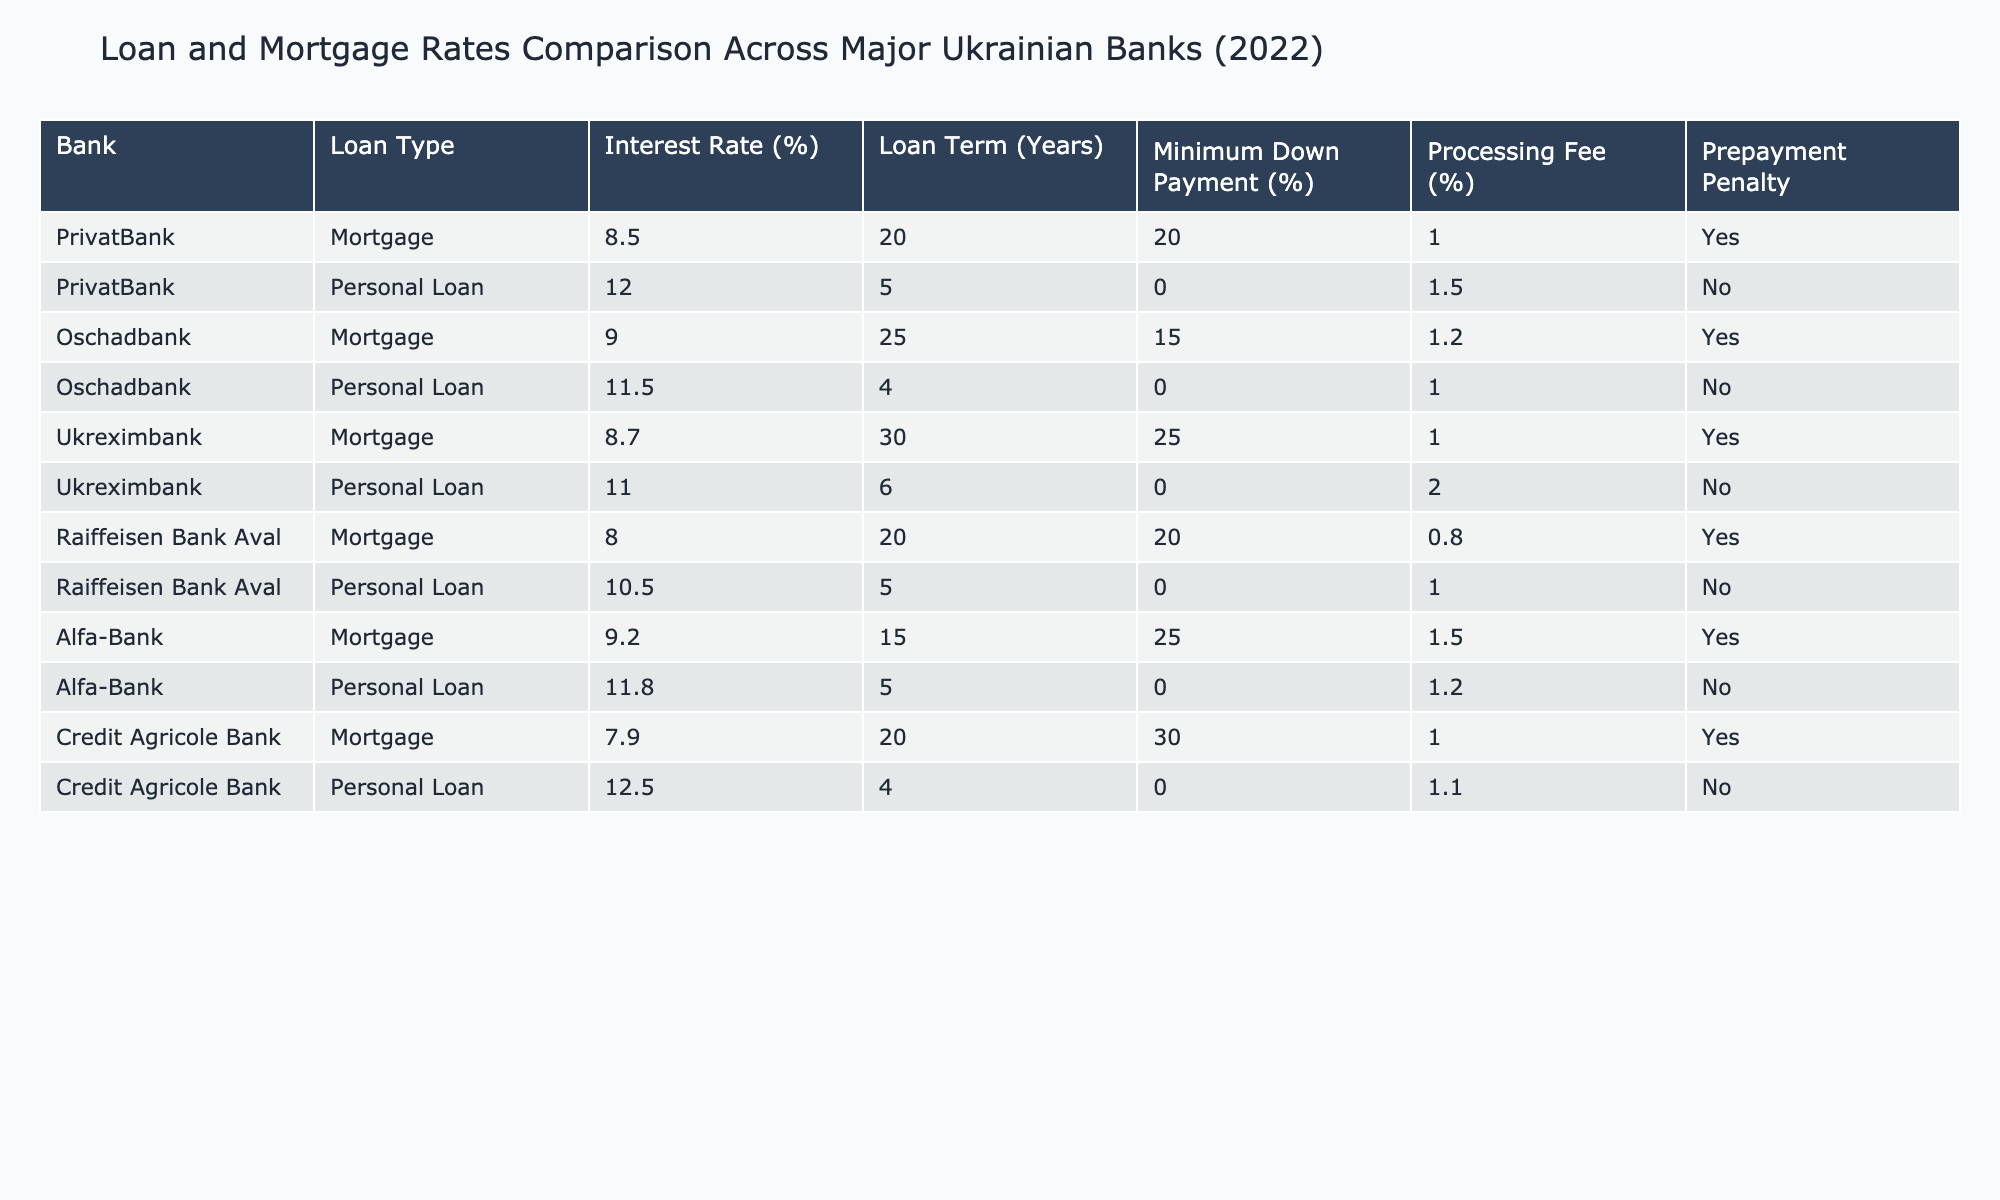What is the interest rate for a mortgage at PrivatBank? The table lists the interest rate for mortgage loans at PrivatBank as 8.5%.
Answer: 8.5% Which bank offers the lowest interest rate for personal loans? By reviewing the personal loan interest rates from each bank, it shows that Raiffeisen Bank Aval has the lowest rate at 10.5%.
Answer: 10.5% What is the maximum loan term available for mortgages at Oschadbank? According to the table, Oschadbank offers mortgage loans with a maximum term of 25 years.
Answer: 25 years Is there a prepayment penalty for loans from Alfa-Bank? The data indicates that for both types of loans At Alfa-Bank, there is no prepayment penalty.
Answer: No What is the difference in interest rates between Credit Agricole Bank’s mortgage and personal loan? The mortgage interest rate is 7.9% and the personal loan rate is 12.5%, so the difference is 12.5% - 7.9% = 4.6%.
Answer: 4.6% How many banks provide mortgages with an interest rate below 9%? The table shows that three banks (Credit Agricole Bank, Raiffeisen Bank Aval, and PrivatBank) offer mortgages with rates below 9%. Therefore, the total is three banks.
Answer: 3 banks What is the average interest rate for mortgages across all banks listed? To find the average, add the interest rates (8.5% + 9.0% + 8.7% + 8.0% + 9.2% + 7.9%) totaling 51.3%. Dividing by 6 (the number of banks) results in an average of 8.55%.
Answer: 8.55% Do Ukreximbank and Oschadbank have prepayment penalties for their mortgage loans? Yes, both banks have a prepayment penalty indicated in the table.
Answer: Yes Which bank has the highest minimum down payment percentage for personal loans? According to the table, PrivtBank and Oschadbank both have a minimum down payment percentage of 0% for personal loans, and no personal loan has a down payment higher than 0%.
Answer: 0% 